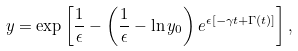Convert formula to latex. <formula><loc_0><loc_0><loc_500><loc_500>y = \exp \left [ \frac { 1 } { \epsilon } - \left ( \frac { 1 } { \epsilon } - \ln { y _ { 0 } } \right ) e ^ { \epsilon [ - \gamma t + \Gamma ( t ) ] } \right ] ,</formula> 